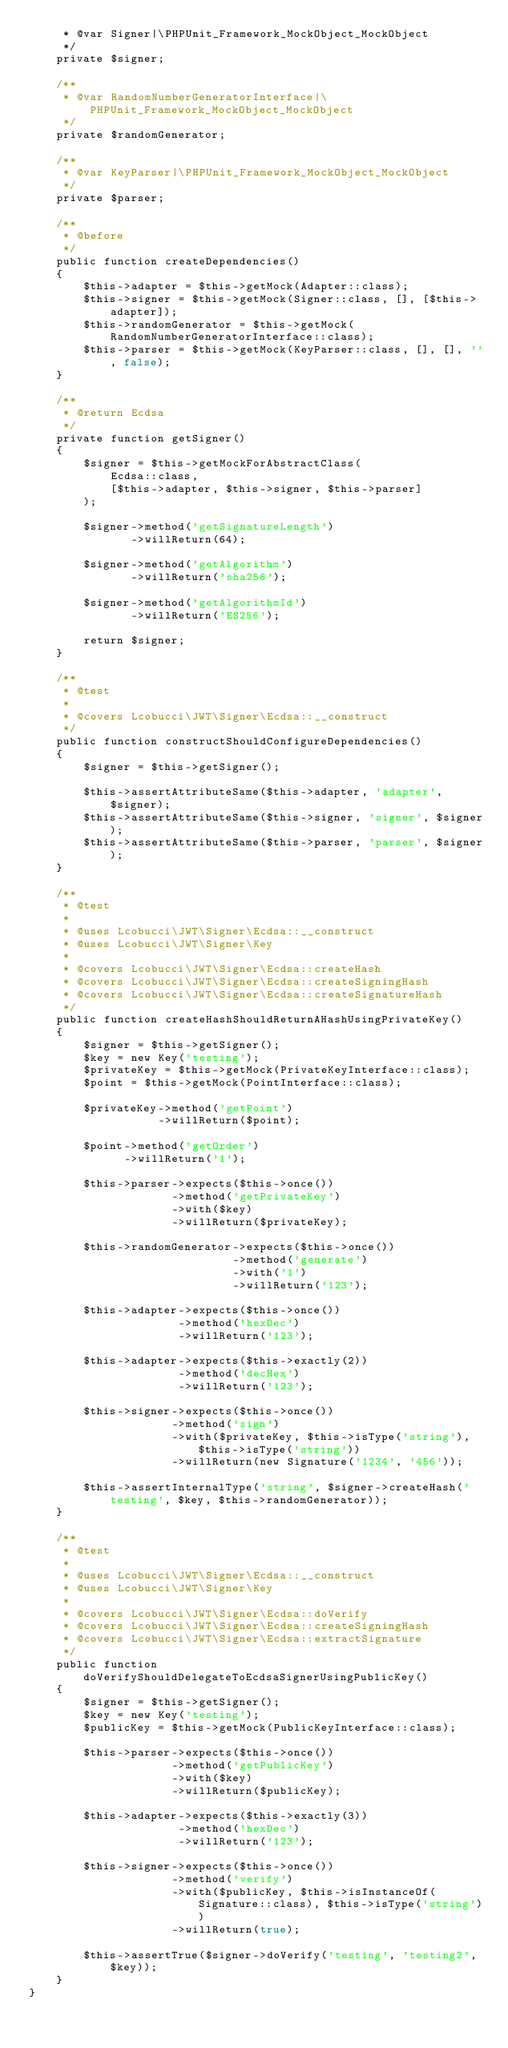Convert code to text. <code><loc_0><loc_0><loc_500><loc_500><_PHP_>     * @var Signer|\PHPUnit_Framework_MockObject_MockObject
     */
    private $signer;

    /**
     * @var RandomNumberGeneratorInterface|\PHPUnit_Framework_MockObject_MockObject
     */
    private $randomGenerator;

    /**
     * @var KeyParser|\PHPUnit_Framework_MockObject_MockObject
     */
    private $parser;

    /**
     * @before
     */
    public function createDependencies()
    {
        $this->adapter = $this->getMock(Adapter::class);
        $this->signer = $this->getMock(Signer::class, [], [$this->adapter]);
        $this->randomGenerator = $this->getMock(RandomNumberGeneratorInterface::class);
        $this->parser = $this->getMock(KeyParser::class, [], [], '', false);
    }

    /**
     * @return Ecdsa
     */
    private function getSigner()
    {
        $signer = $this->getMockForAbstractClass(
            Ecdsa::class,
            [$this->adapter, $this->signer, $this->parser]
        );

        $signer->method('getSignatureLength')
               ->willReturn(64);

        $signer->method('getAlgorithm')
               ->willReturn('sha256');

        $signer->method('getAlgorithmId')
               ->willReturn('ES256');

        return $signer;
    }

    /**
     * @test
     *
     * @covers Lcobucci\JWT\Signer\Ecdsa::__construct
     */
    public function constructShouldConfigureDependencies()
    {
        $signer = $this->getSigner();

        $this->assertAttributeSame($this->adapter, 'adapter', $signer);
        $this->assertAttributeSame($this->signer, 'signer', $signer);
        $this->assertAttributeSame($this->parser, 'parser', $signer);
    }

    /**
     * @test
     *
     * @uses Lcobucci\JWT\Signer\Ecdsa::__construct
     * @uses Lcobucci\JWT\Signer\Key
     *
     * @covers Lcobucci\JWT\Signer\Ecdsa::createHash
     * @covers Lcobucci\JWT\Signer\Ecdsa::createSigningHash
     * @covers Lcobucci\JWT\Signer\Ecdsa::createSignatureHash
     */
    public function createHashShouldReturnAHashUsingPrivateKey()
    {
        $signer = $this->getSigner();
        $key = new Key('testing');
        $privateKey = $this->getMock(PrivateKeyInterface::class);
        $point = $this->getMock(PointInterface::class);

        $privateKey->method('getPoint')
                   ->willReturn($point);

        $point->method('getOrder')
              ->willReturn('1');

        $this->parser->expects($this->once())
                     ->method('getPrivateKey')
                     ->with($key)
                     ->willReturn($privateKey);

        $this->randomGenerator->expects($this->once())
                              ->method('generate')
                              ->with('1')
                              ->willReturn('123');

        $this->adapter->expects($this->once())
                      ->method('hexDec')
                      ->willReturn('123');

        $this->adapter->expects($this->exactly(2))
                      ->method('decHex')
                      ->willReturn('123');

        $this->signer->expects($this->once())
                     ->method('sign')
                     ->with($privateKey, $this->isType('string'), $this->isType('string'))
                     ->willReturn(new Signature('1234', '456'));

        $this->assertInternalType('string', $signer->createHash('testing', $key, $this->randomGenerator));
    }

    /**
     * @test
     *
     * @uses Lcobucci\JWT\Signer\Ecdsa::__construct
     * @uses Lcobucci\JWT\Signer\Key
     *
     * @covers Lcobucci\JWT\Signer\Ecdsa::doVerify
     * @covers Lcobucci\JWT\Signer\Ecdsa::createSigningHash
     * @covers Lcobucci\JWT\Signer\Ecdsa::extractSignature
     */
    public function doVerifyShouldDelegateToEcdsaSignerUsingPublicKey()
    {
        $signer = $this->getSigner();
        $key = new Key('testing');
        $publicKey = $this->getMock(PublicKeyInterface::class);

        $this->parser->expects($this->once())
                     ->method('getPublicKey')
                     ->with($key)
                     ->willReturn($publicKey);

        $this->adapter->expects($this->exactly(3))
                      ->method('hexDec')
                      ->willReturn('123');

        $this->signer->expects($this->once())
                     ->method('verify')
                     ->with($publicKey, $this->isInstanceOf(Signature::class), $this->isType('string'))
                     ->willReturn(true);

        $this->assertTrue($signer->doVerify('testing', 'testing2', $key));
    }
}
</code> 